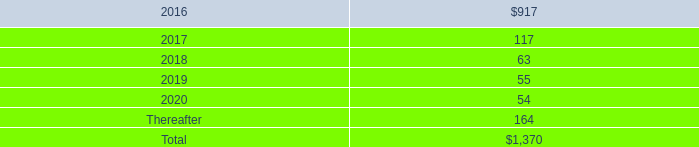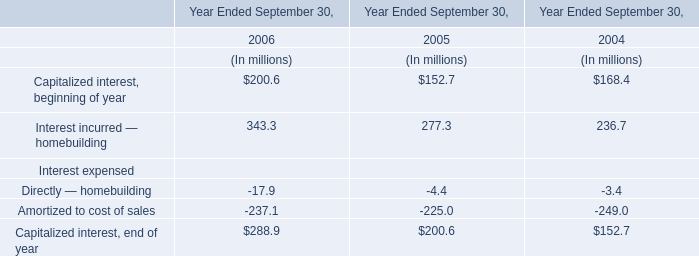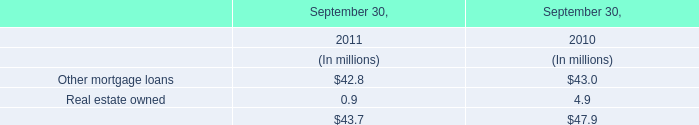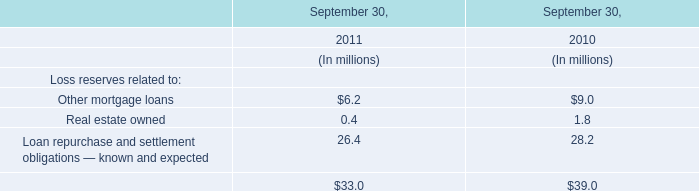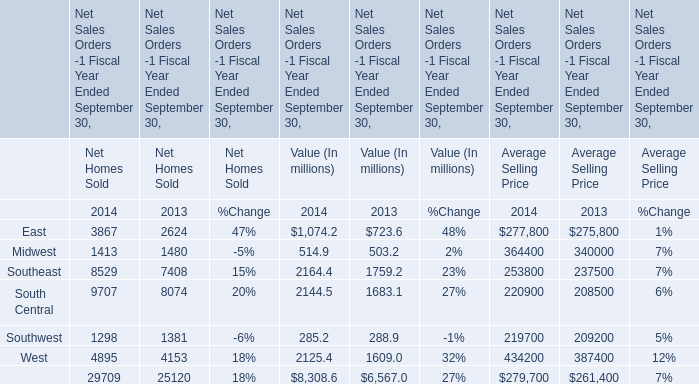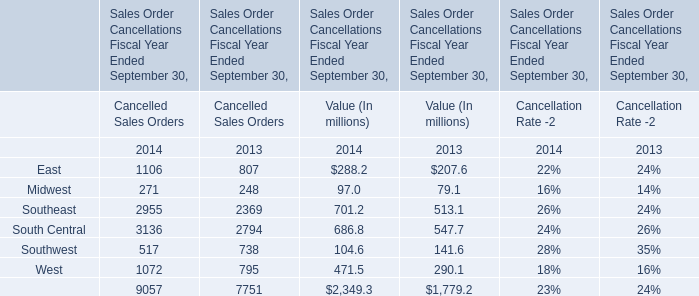What is the difference between 2013 and 2014 's highest Net Homes Sold? (in million) 
Computations: (9707 - 8074)
Answer: 1633.0. 